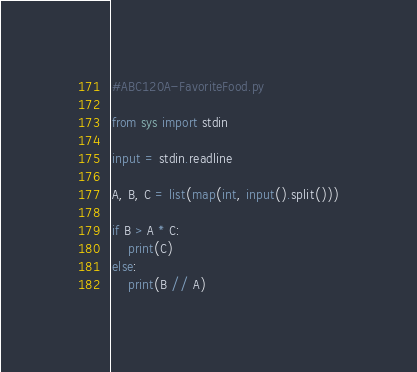<code> <loc_0><loc_0><loc_500><loc_500><_Python_>#ABC120A-FavoriteFood.py

from sys import stdin

input = stdin.readline

A, B, C = list(map(int, input().split()))

if B > A * C:
    print(C)
else:
    print(B // A)
</code> 